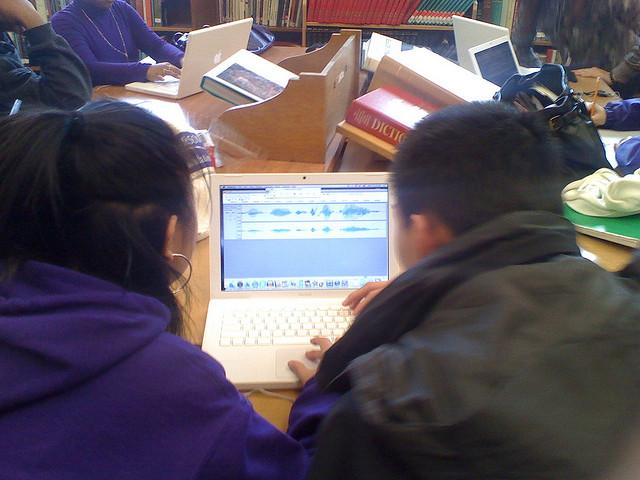Without the computers where would they look up definitions? dictionary 